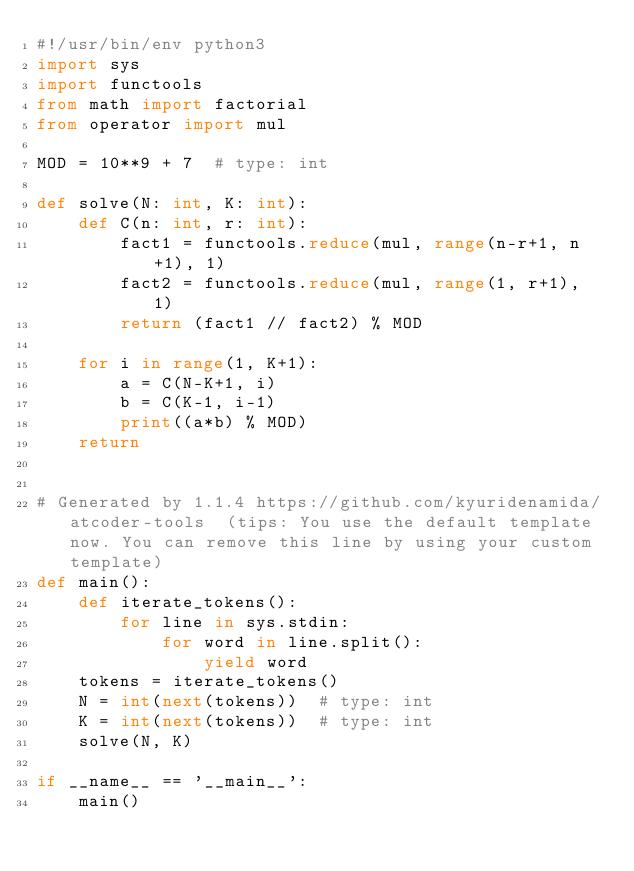Convert code to text. <code><loc_0><loc_0><loc_500><loc_500><_Python_>#!/usr/bin/env python3
import sys
import functools
from math import factorial
from operator import mul

MOD = 10**9 + 7  # type: int

def solve(N: int, K: int):
    def C(n: int, r: int):
        fact1 = functools.reduce(mul, range(n-r+1, n+1), 1)
        fact2 = functools.reduce(mul, range(1, r+1), 1)
        return (fact1 // fact2) % MOD

    for i in range(1, K+1):
        a = C(N-K+1, i)
        b = C(K-1, i-1)
        print((a*b) % MOD)
    return


# Generated by 1.1.4 https://github.com/kyuridenamida/atcoder-tools  (tips: You use the default template now. You can remove this line by using your custom template)
def main():
    def iterate_tokens():
        for line in sys.stdin:
            for word in line.split():
                yield word
    tokens = iterate_tokens()
    N = int(next(tokens))  # type: int
    K = int(next(tokens))  # type: int
    solve(N, K)

if __name__ == '__main__':
    main()
</code> 